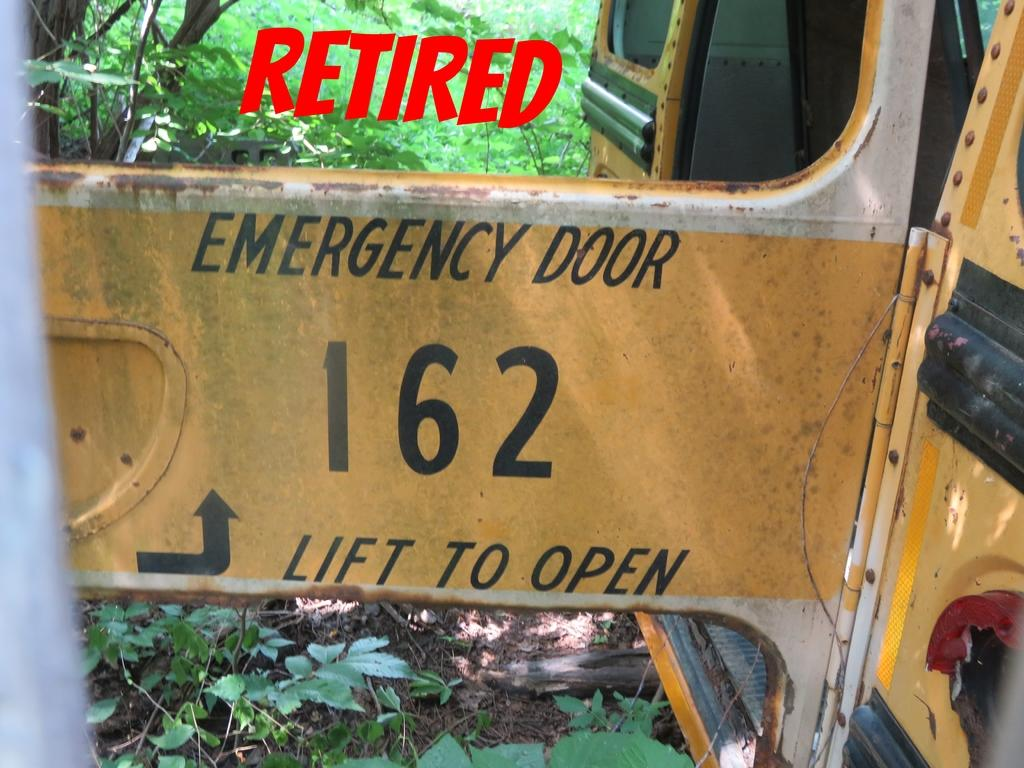What is the main subject of the image? There is a vehicle in the image. What can be seen in the background of the image? There are trees visible behind the vehicle in the image. What type of fruit is being cut by the scissors in the image? There are no scissors or fruit present in the image; it only features a vehicle and trees in the background. 